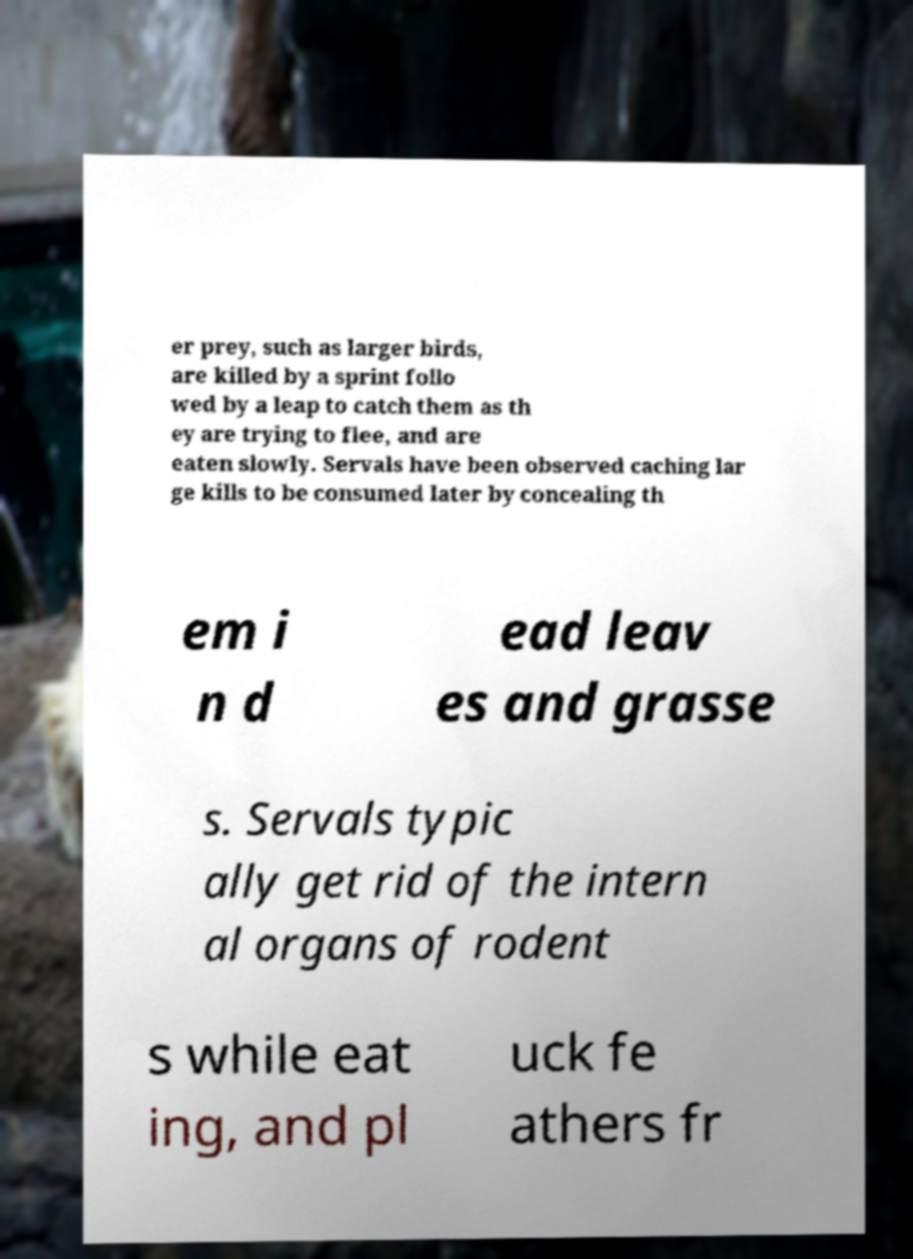Can you accurately transcribe the text from the provided image for me? er prey, such as larger birds, are killed by a sprint follo wed by a leap to catch them as th ey are trying to flee, and are eaten slowly. Servals have been observed caching lar ge kills to be consumed later by concealing th em i n d ead leav es and grasse s. Servals typic ally get rid of the intern al organs of rodent s while eat ing, and pl uck fe athers fr 